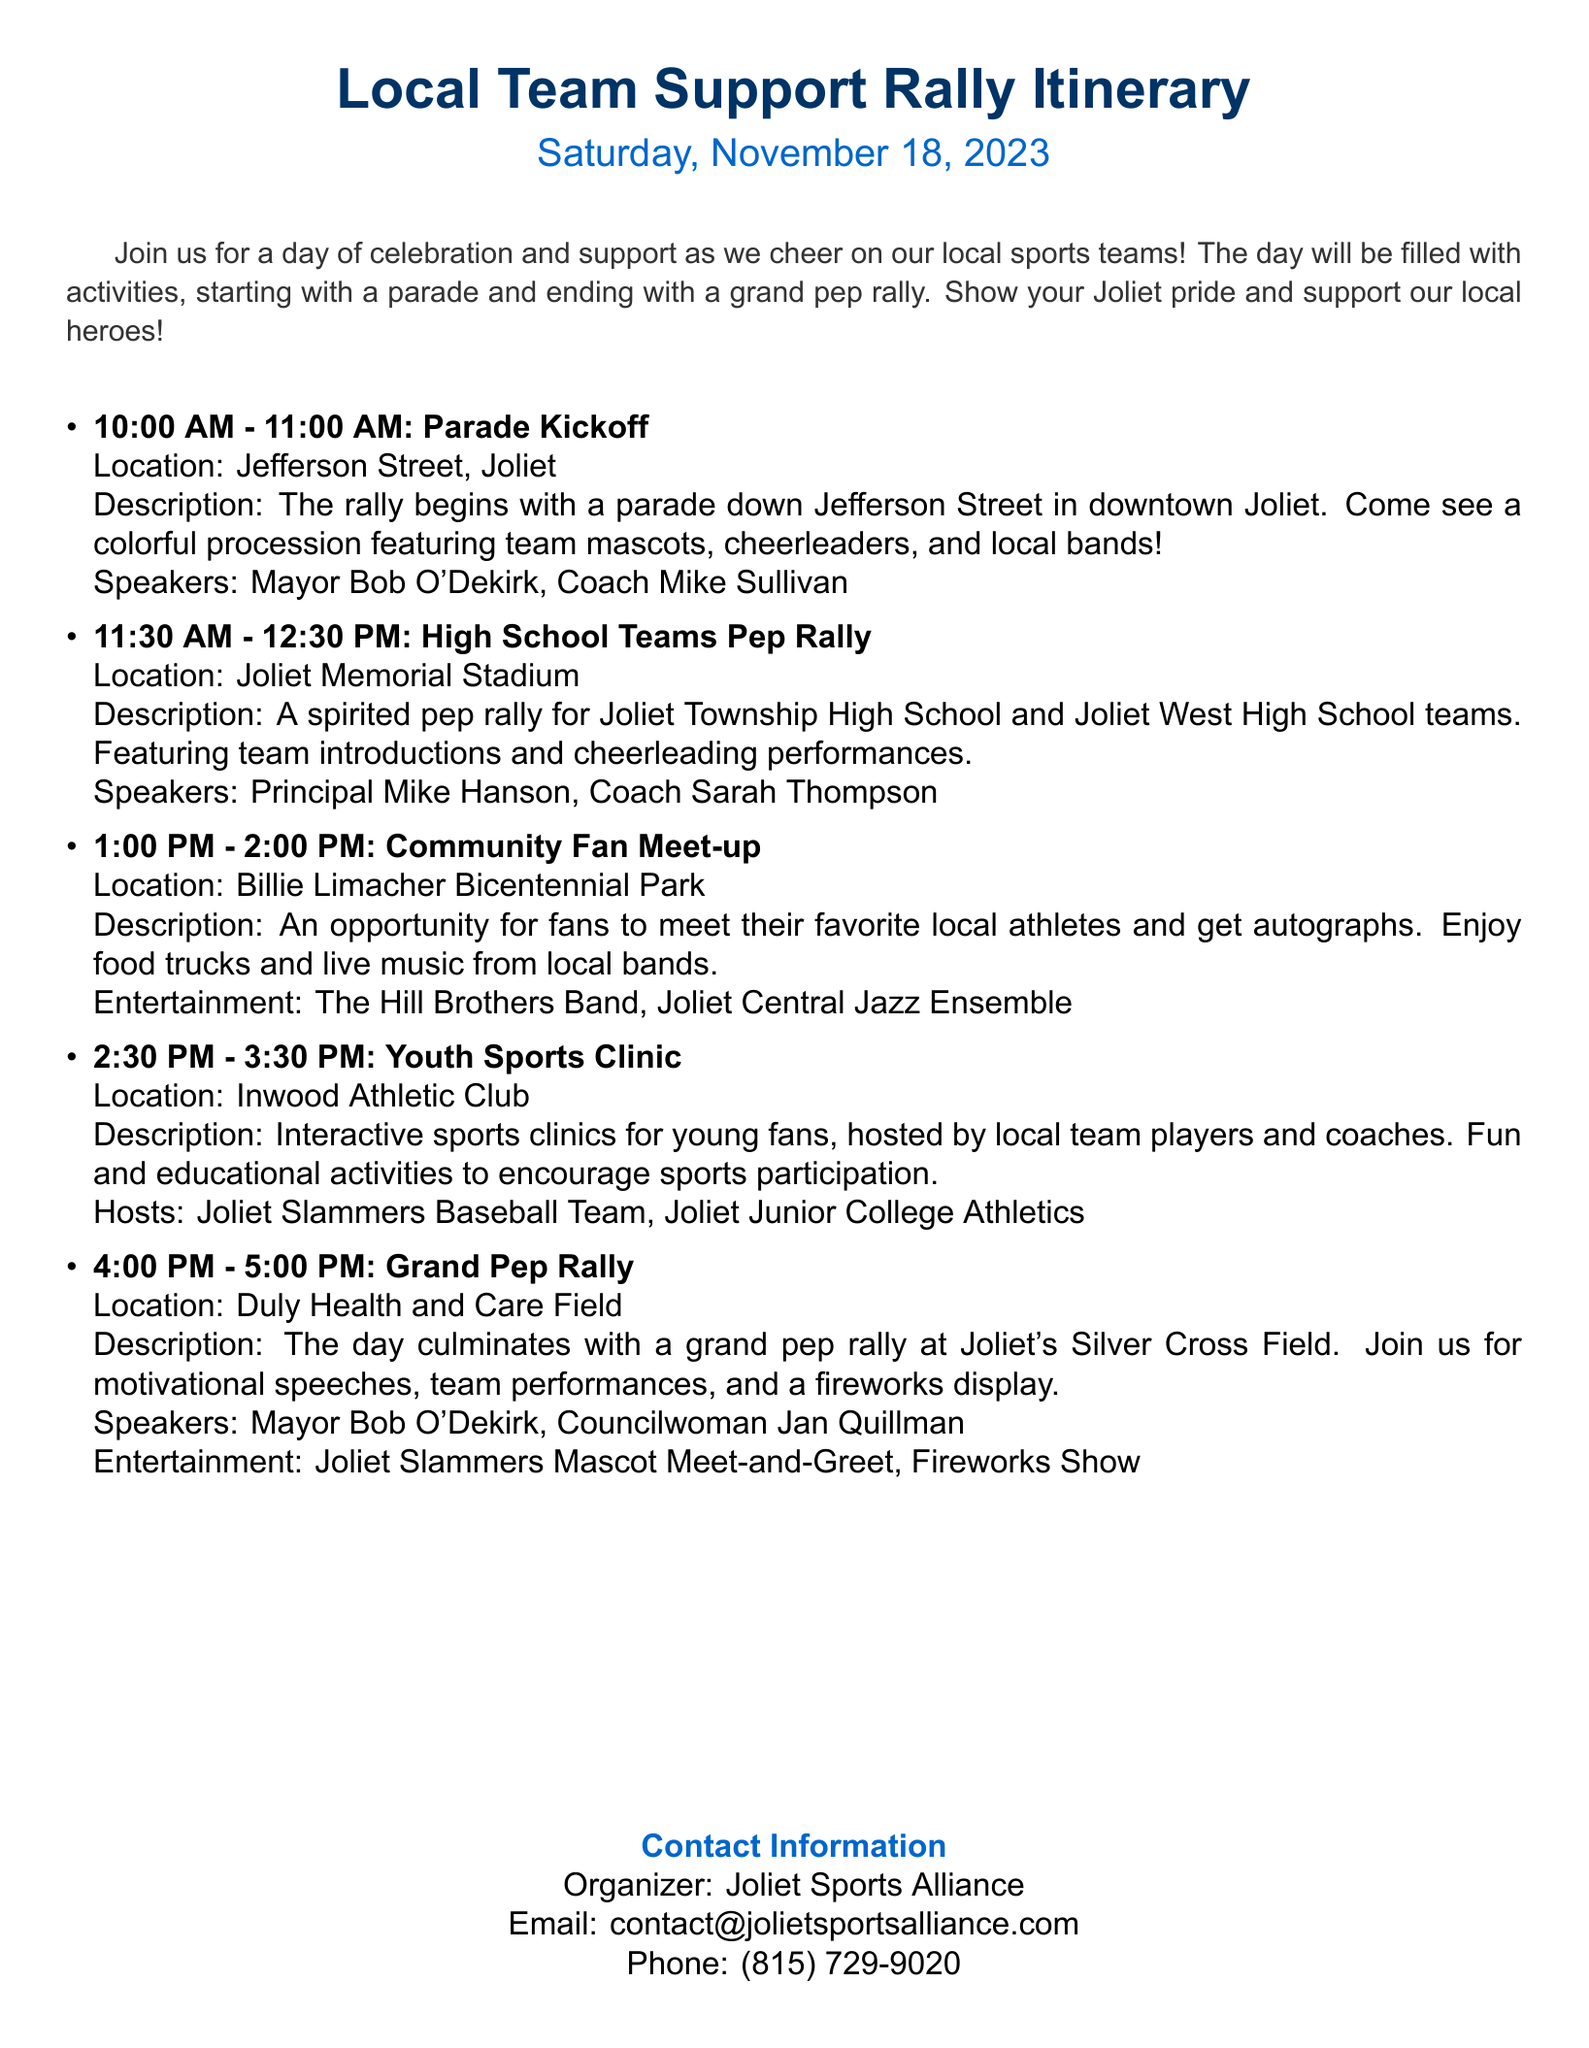What time does the parade kickoff? The parade kickoff is scheduled for 10:00 AM on the itinerary.
Answer: 10:00 AM Who is one of the speakers at the Grand Pep Rally? The itinerary lists Mayor Bob O'Dekirk as a speaker at the Grand Pep Rally.
Answer: Mayor Bob O'Dekirk Where is the High School Teams Pep Rally held? The location for the High School Teams Pep Rally is Joliet Memorial Stadium according to the document.
Answer: Joliet Memorial Stadium What entertainment will be featured at the Community Fan Meet-up? The entertainment mentioned for the Community Fan Meet-up includes The Hill Brothers Band and the Joliet Central Jazz Ensemble.
Answer: The Hill Brothers Band, Joliet Central Jazz Ensemble How long is the Youth Sports Clinic? The itinerary states that the Youth Sports Clinic is scheduled for 1 hour from 2:30 PM to 3:30 PM.
Answer: 1 hour What is the final event of the day? The final event mentioned in the itinerary is the Grand Pep Rally.
Answer: Grand Pep Rally What is the date of the Local Team Support Rally? The date for the Local Team Support Rally is specified as Saturday, November 18, 2023.
Answer: Saturday, November 18, 2023 Who should be contacted for more information about the rally? The itinerary provides the organizer, Joliet Sports Alliance, as the contact for more information.
Answer: Joliet Sports Alliance What time does the Community Fan Meet-up start? According to the document, the Community Fan Meet-up starts at 1:00 PM.
Answer: 1:00 PM 